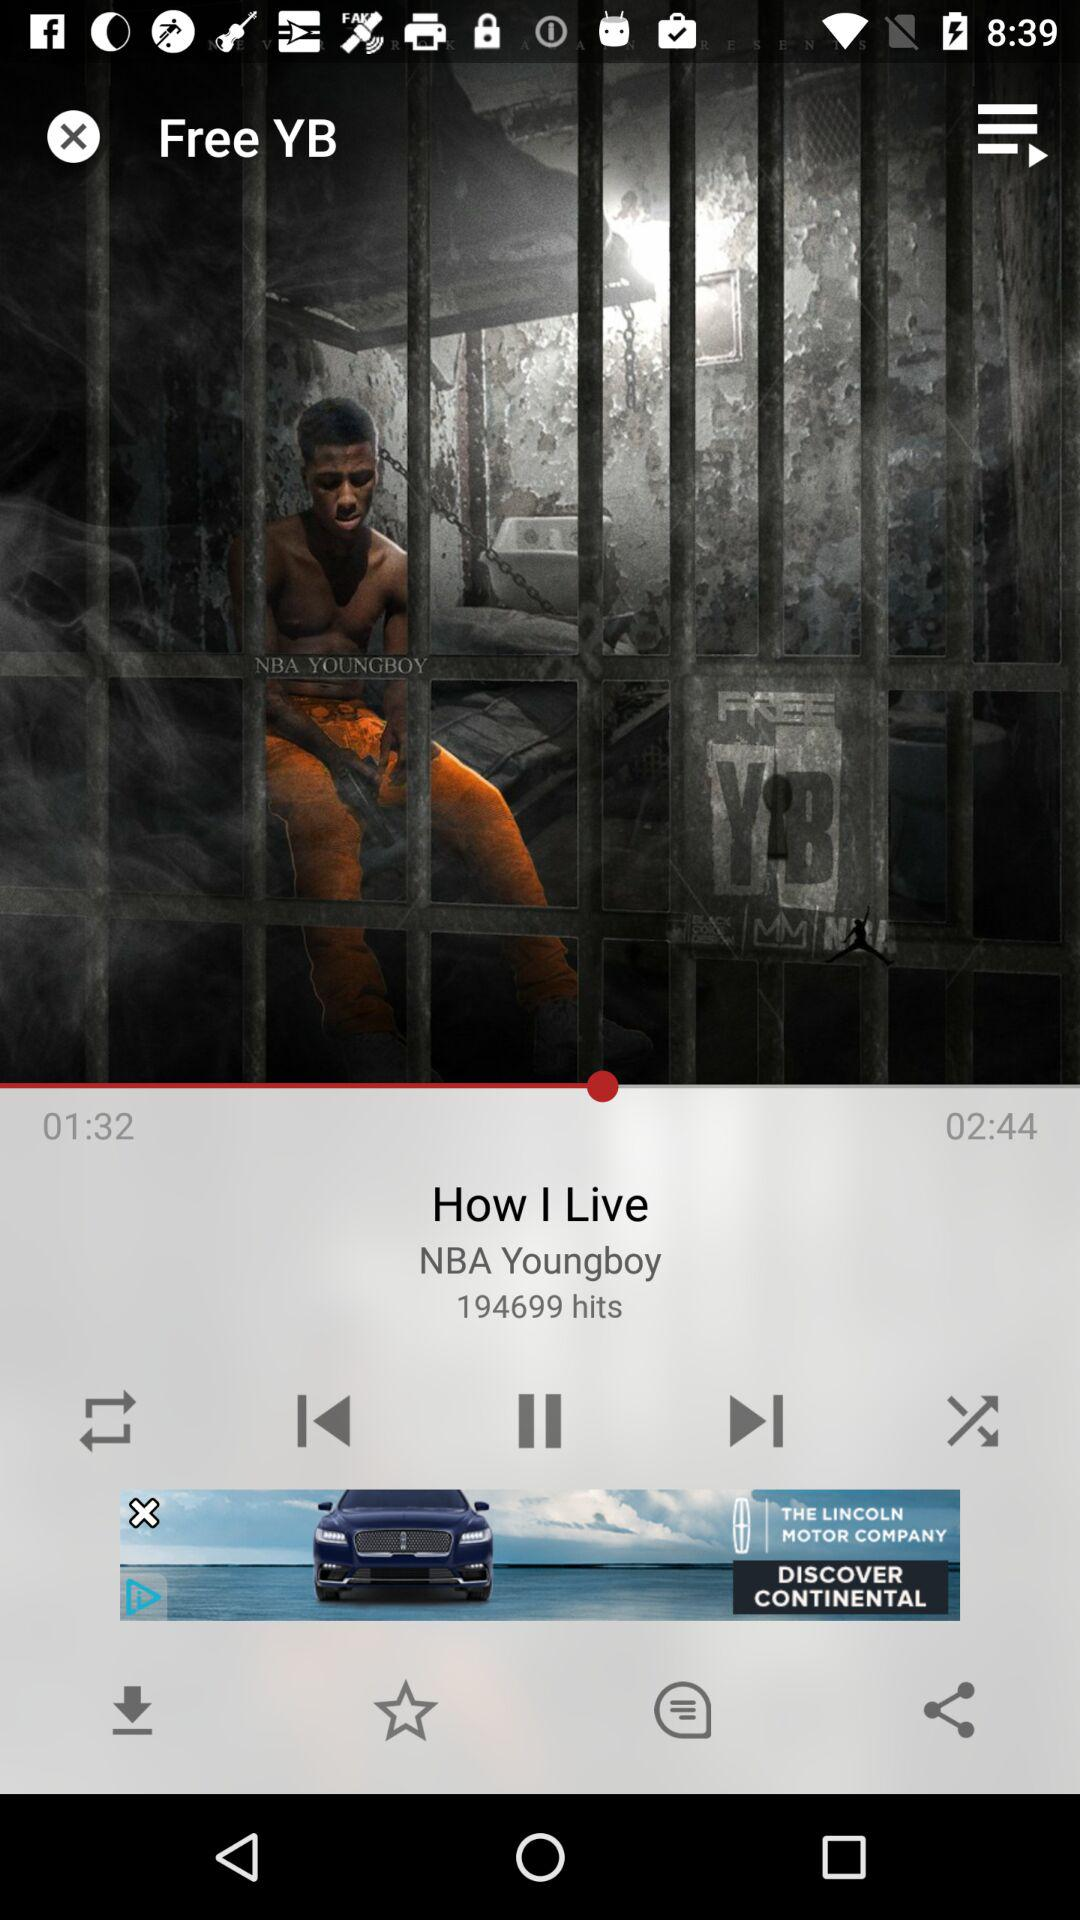Which song is playing? The playing song is "How I Live". 